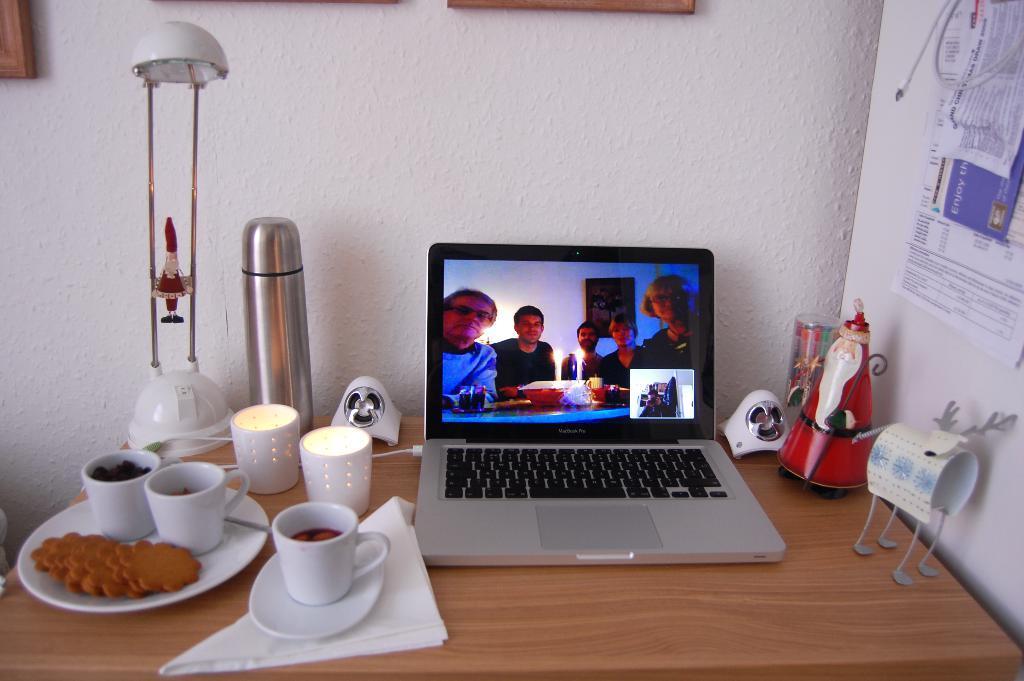Please provide a concise description of this image. In this image there is table, on which a laptop, speakers, cups and saucers, along with biscuits are kept. In the background there is a wall along with wooden frames on it. And to the right there is a board on which some papers are pasted. 